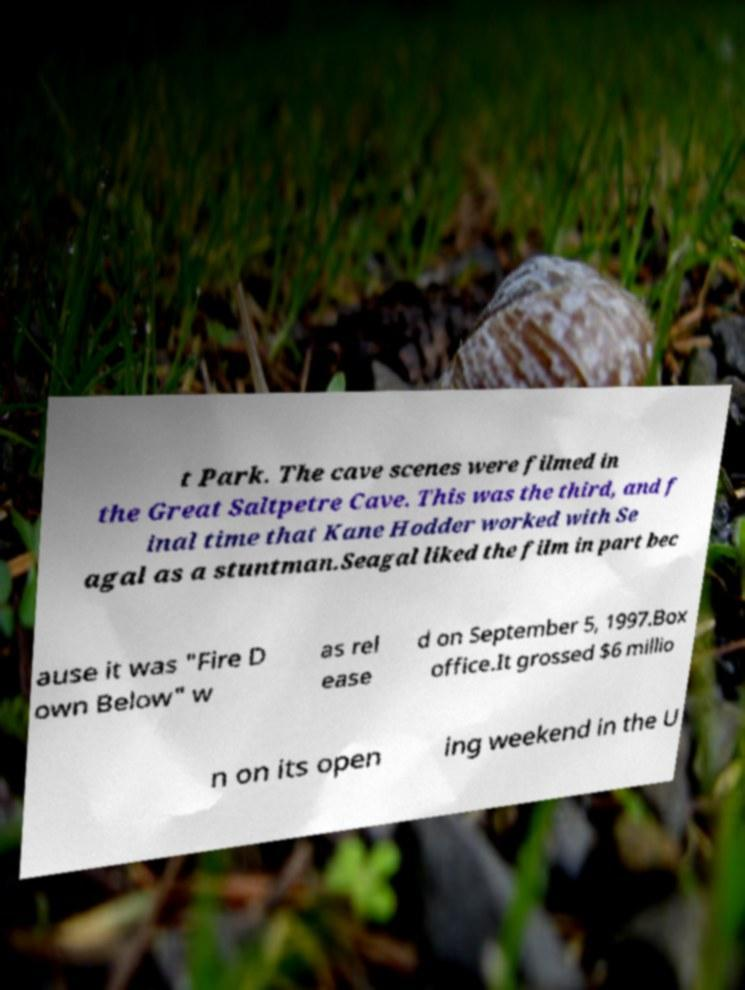There's text embedded in this image that I need extracted. Can you transcribe it verbatim? t Park. The cave scenes were filmed in the Great Saltpetre Cave. This was the third, and f inal time that Kane Hodder worked with Se agal as a stuntman.Seagal liked the film in part bec ause it was "Fire D own Below" w as rel ease d on September 5, 1997.Box office.It grossed $6 millio n on its open ing weekend in the U 